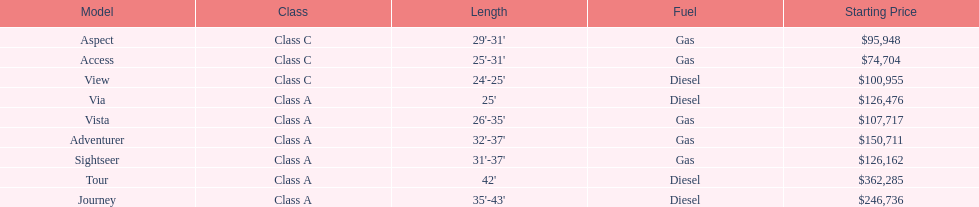Does the tour take diesel or gas? Diesel. 